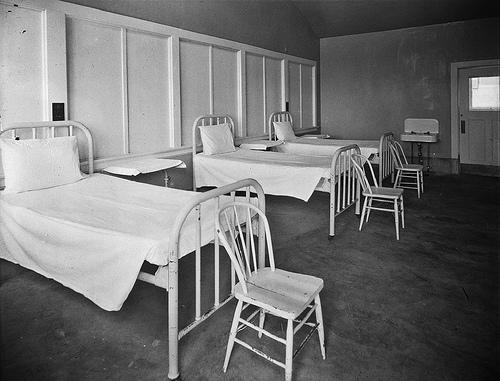This room looks like an old type of what? Please explain your reasoning. hospital. The room has metallic beds but does not have prison cells. churches and schools do not have beds. 